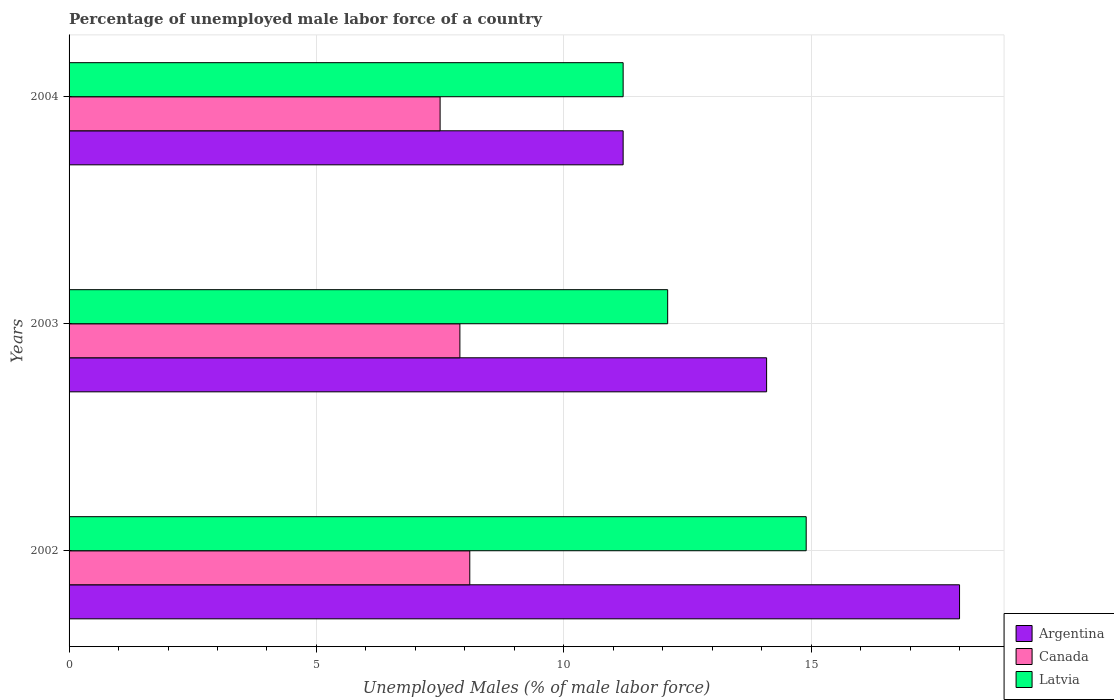Are the number of bars on each tick of the Y-axis equal?
Provide a succinct answer. Yes. What is the label of the 1st group of bars from the top?
Your response must be concise. 2004. In how many cases, is the number of bars for a given year not equal to the number of legend labels?
Provide a short and direct response. 0. What is the percentage of unemployed male labor force in Argentina in 2003?
Provide a short and direct response. 14.1. Across all years, what is the maximum percentage of unemployed male labor force in Canada?
Make the answer very short. 8.1. Across all years, what is the minimum percentage of unemployed male labor force in Latvia?
Ensure brevity in your answer.  11.2. What is the total percentage of unemployed male labor force in Canada in the graph?
Offer a very short reply. 23.5. What is the difference between the percentage of unemployed male labor force in Argentina in 2003 and that in 2004?
Provide a succinct answer. 2.9. What is the difference between the percentage of unemployed male labor force in Latvia in 2004 and the percentage of unemployed male labor force in Canada in 2003?
Provide a short and direct response. 3.3. What is the average percentage of unemployed male labor force in Argentina per year?
Give a very brief answer. 14.43. In the year 2004, what is the difference between the percentage of unemployed male labor force in Latvia and percentage of unemployed male labor force in Canada?
Offer a very short reply. 3.7. In how many years, is the percentage of unemployed male labor force in Canada greater than 10 %?
Make the answer very short. 0. What is the ratio of the percentage of unemployed male labor force in Argentina in 2003 to that in 2004?
Your response must be concise. 1.26. Is the difference between the percentage of unemployed male labor force in Latvia in 2003 and 2004 greater than the difference between the percentage of unemployed male labor force in Canada in 2003 and 2004?
Your response must be concise. Yes. What is the difference between the highest and the second highest percentage of unemployed male labor force in Argentina?
Offer a terse response. 3.9. What is the difference between the highest and the lowest percentage of unemployed male labor force in Latvia?
Your response must be concise. 3.7. In how many years, is the percentage of unemployed male labor force in Canada greater than the average percentage of unemployed male labor force in Canada taken over all years?
Your answer should be compact. 2. What does the 3rd bar from the top in 2003 represents?
Make the answer very short. Argentina. What is the difference between two consecutive major ticks on the X-axis?
Offer a very short reply. 5. Are the values on the major ticks of X-axis written in scientific E-notation?
Give a very brief answer. No. How many legend labels are there?
Your answer should be very brief. 3. How are the legend labels stacked?
Give a very brief answer. Vertical. What is the title of the graph?
Offer a very short reply. Percentage of unemployed male labor force of a country. What is the label or title of the X-axis?
Give a very brief answer. Unemployed Males (% of male labor force). What is the Unemployed Males (% of male labor force) of Argentina in 2002?
Offer a very short reply. 18. What is the Unemployed Males (% of male labor force) in Canada in 2002?
Provide a succinct answer. 8.1. What is the Unemployed Males (% of male labor force) in Latvia in 2002?
Provide a succinct answer. 14.9. What is the Unemployed Males (% of male labor force) of Argentina in 2003?
Your response must be concise. 14.1. What is the Unemployed Males (% of male labor force) of Canada in 2003?
Your answer should be very brief. 7.9. What is the Unemployed Males (% of male labor force) in Latvia in 2003?
Give a very brief answer. 12.1. What is the Unemployed Males (% of male labor force) of Argentina in 2004?
Ensure brevity in your answer.  11.2. What is the Unemployed Males (% of male labor force) of Canada in 2004?
Your answer should be compact. 7.5. What is the Unemployed Males (% of male labor force) of Latvia in 2004?
Your response must be concise. 11.2. Across all years, what is the maximum Unemployed Males (% of male labor force) in Argentina?
Give a very brief answer. 18. Across all years, what is the maximum Unemployed Males (% of male labor force) in Canada?
Your answer should be very brief. 8.1. Across all years, what is the maximum Unemployed Males (% of male labor force) in Latvia?
Offer a very short reply. 14.9. Across all years, what is the minimum Unemployed Males (% of male labor force) of Argentina?
Your answer should be very brief. 11.2. Across all years, what is the minimum Unemployed Males (% of male labor force) in Canada?
Keep it short and to the point. 7.5. Across all years, what is the minimum Unemployed Males (% of male labor force) of Latvia?
Ensure brevity in your answer.  11.2. What is the total Unemployed Males (% of male labor force) of Argentina in the graph?
Keep it short and to the point. 43.3. What is the total Unemployed Males (% of male labor force) of Latvia in the graph?
Your answer should be very brief. 38.2. What is the difference between the Unemployed Males (% of male labor force) in Argentina in 2002 and that in 2003?
Offer a terse response. 3.9. What is the difference between the Unemployed Males (% of male labor force) in Canada in 2002 and that in 2003?
Provide a succinct answer. 0.2. What is the difference between the Unemployed Males (% of male labor force) of Latvia in 2002 and that in 2003?
Keep it short and to the point. 2.8. What is the difference between the Unemployed Males (% of male labor force) of Canada in 2003 and that in 2004?
Provide a short and direct response. 0.4. What is the difference between the Unemployed Males (% of male labor force) in Argentina in 2002 and the Unemployed Males (% of male labor force) in Latvia in 2003?
Keep it short and to the point. 5.9. What is the difference between the Unemployed Males (% of male labor force) of Canada in 2002 and the Unemployed Males (% of male labor force) of Latvia in 2004?
Ensure brevity in your answer.  -3.1. What is the difference between the Unemployed Males (% of male labor force) in Argentina in 2003 and the Unemployed Males (% of male labor force) in Canada in 2004?
Provide a succinct answer. 6.6. What is the difference between the Unemployed Males (% of male labor force) in Canada in 2003 and the Unemployed Males (% of male labor force) in Latvia in 2004?
Your answer should be very brief. -3.3. What is the average Unemployed Males (% of male labor force) in Argentina per year?
Ensure brevity in your answer.  14.43. What is the average Unemployed Males (% of male labor force) in Canada per year?
Keep it short and to the point. 7.83. What is the average Unemployed Males (% of male labor force) of Latvia per year?
Offer a very short reply. 12.73. In the year 2002, what is the difference between the Unemployed Males (% of male labor force) in Argentina and Unemployed Males (% of male labor force) in Canada?
Give a very brief answer. 9.9. In the year 2002, what is the difference between the Unemployed Males (% of male labor force) of Canada and Unemployed Males (% of male labor force) of Latvia?
Your answer should be very brief. -6.8. In the year 2003, what is the difference between the Unemployed Males (% of male labor force) of Argentina and Unemployed Males (% of male labor force) of Canada?
Provide a short and direct response. 6.2. In the year 2004, what is the difference between the Unemployed Males (% of male labor force) in Argentina and Unemployed Males (% of male labor force) in Latvia?
Provide a succinct answer. 0. What is the ratio of the Unemployed Males (% of male labor force) of Argentina in 2002 to that in 2003?
Make the answer very short. 1.28. What is the ratio of the Unemployed Males (% of male labor force) of Canada in 2002 to that in 2003?
Provide a succinct answer. 1.03. What is the ratio of the Unemployed Males (% of male labor force) in Latvia in 2002 to that in 2003?
Offer a very short reply. 1.23. What is the ratio of the Unemployed Males (% of male labor force) in Argentina in 2002 to that in 2004?
Your answer should be very brief. 1.61. What is the ratio of the Unemployed Males (% of male labor force) in Canada in 2002 to that in 2004?
Your answer should be very brief. 1.08. What is the ratio of the Unemployed Males (% of male labor force) in Latvia in 2002 to that in 2004?
Provide a succinct answer. 1.33. What is the ratio of the Unemployed Males (% of male labor force) in Argentina in 2003 to that in 2004?
Make the answer very short. 1.26. What is the ratio of the Unemployed Males (% of male labor force) in Canada in 2003 to that in 2004?
Provide a succinct answer. 1.05. What is the ratio of the Unemployed Males (% of male labor force) of Latvia in 2003 to that in 2004?
Provide a short and direct response. 1.08. What is the difference between the highest and the second highest Unemployed Males (% of male labor force) in Canada?
Offer a terse response. 0.2. What is the difference between the highest and the second highest Unemployed Males (% of male labor force) of Latvia?
Provide a succinct answer. 2.8. What is the difference between the highest and the lowest Unemployed Males (% of male labor force) of Argentina?
Make the answer very short. 6.8. What is the difference between the highest and the lowest Unemployed Males (% of male labor force) in Canada?
Ensure brevity in your answer.  0.6. 